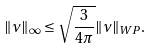Convert formula to latex. <formula><loc_0><loc_0><loc_500><loc_500>\| \nu \| _ { \infty } \leq \sqrt { \frac { 3 } { 4 \pi } } \| \nu \| _ { W P } .</formula> 